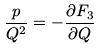Convert formula to latex. <formula><loc_0><loc_0><loc_500><loc_500>\frac { p } { Q ^ { 2 } } = - \frac { \partial F _ { 3 } } { \partial Q }</formula> 